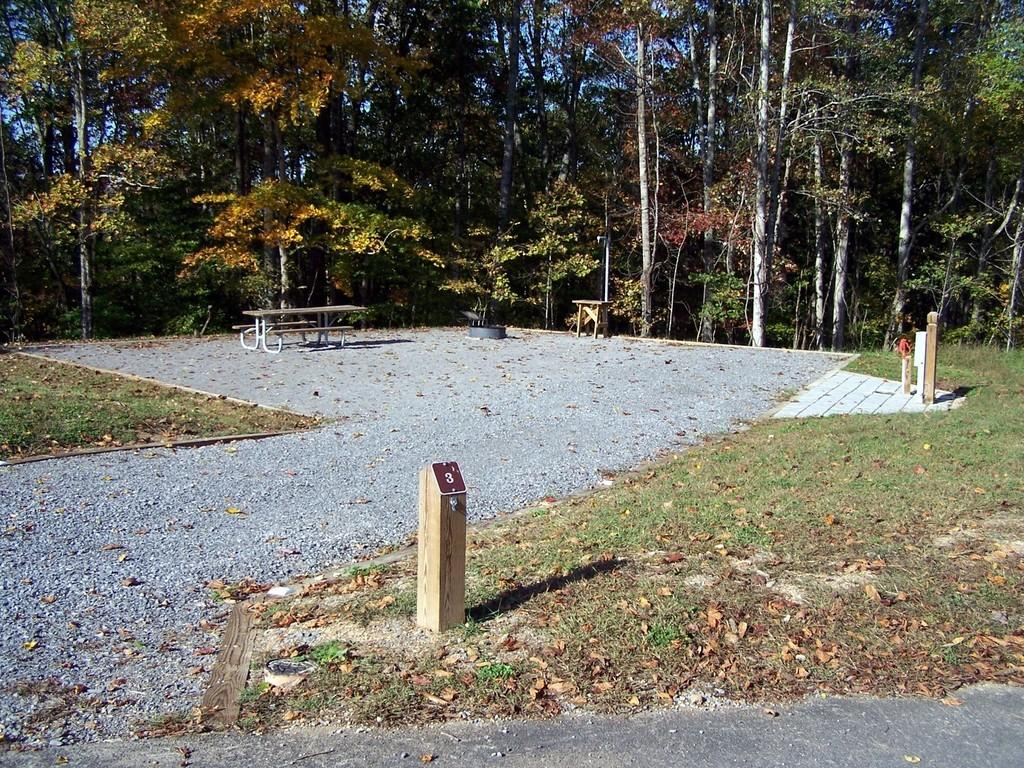What is located on the left side of the image? There is a bench and grass on the left side of the image. What object can be seen in the center of the image? There is a table on the ground in the center of the image. What type of vegetation is visible in the background of the image? There are many trees in the background of the image. What part of the natural environment is visible in the background of the image? The sky is visible in the background of the image. Can you see a twig being used for jumping in the image? There is no twig or jumping activity present in the image. What type of self-portrait is visible in the image? There is no self-portrait present in the image. 